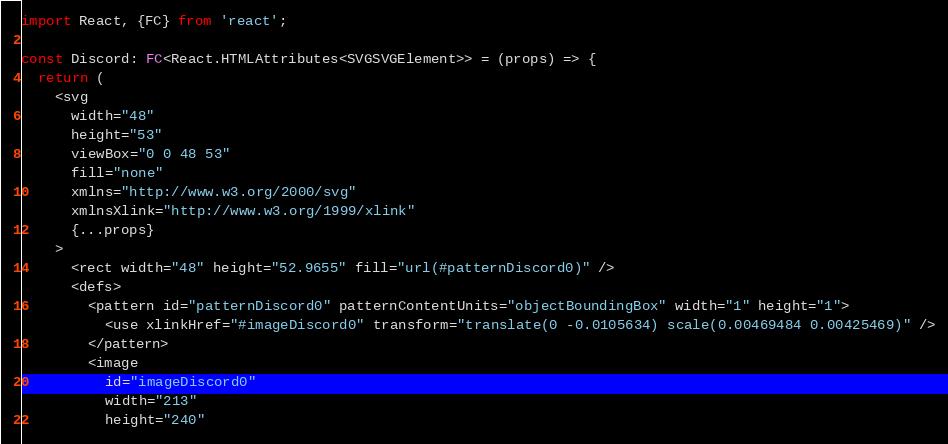Convert code to text. <code><loc_0><loc_0><loc_500><loc_500><_TypeScript_>import React, {FC} from 'react';

const Discord: FC<React.HTMLAttributes<SVGSVGElement>> = (props) => {
  return (
    <svg
      width="48"
      height="53"
      viewBox="0 0 48 53"
      fill="none"
      xmlns="http://www.w3.org/2000/svg"
      xmlnsXlink="http://www.w3.org/1999/xlink"
      {...props}
    >
      <rect width="48" height="52.9655" fill="url(#patternDiscord0)" />
      <defs>
        <pattern id="patternDiscord0" patternContentUnits="objectBoundingBox" width="1" height="1">
          <use xlinkHref="#imageDiscord0" transform="translate(0 -0.0105634) scale(0.00469484 0.00425469)" />
        </pattern>
        <image
          id="imageDiscord0"
          width="213"
          height="240"</code> 